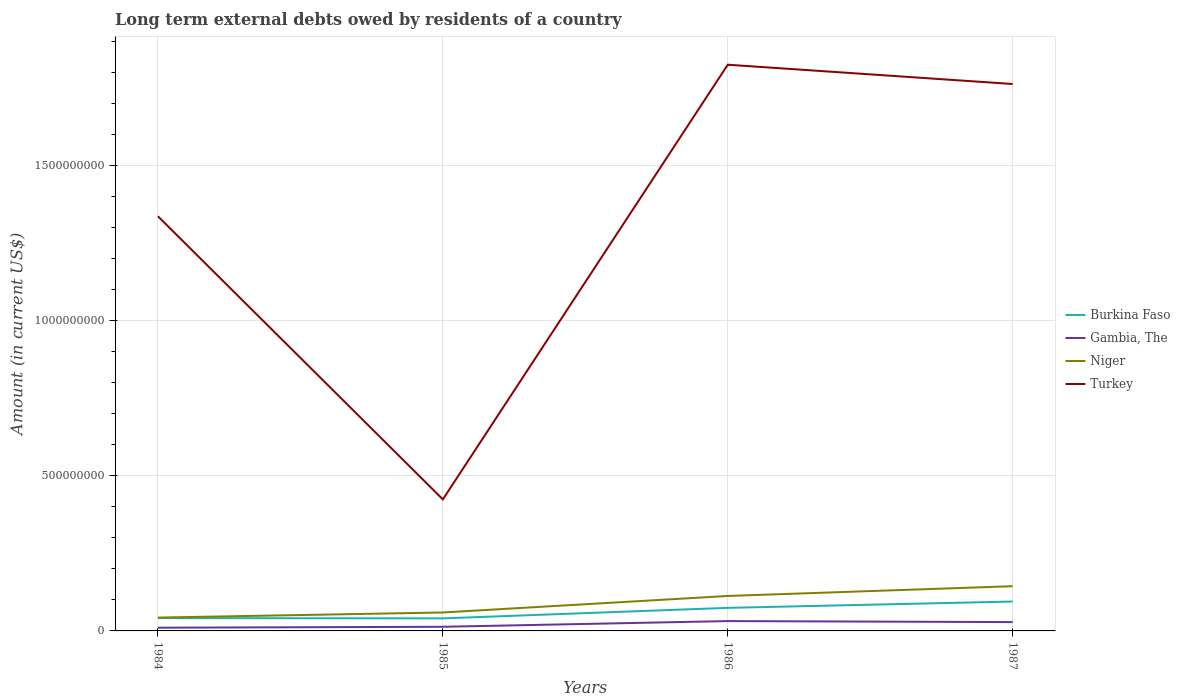How many different coloured lines are there?
Offer a very short reply. 4. Across all years, what is the maximum amount of long-term external debts owed by residents in Turkey?
Your response must be concise. 4.24e+08. What is the total amount of long-term external debts owed by residents in Burkina Faso in the graph?
Make the answer very short. 9.12e+05. What is the difference between the highest and the second highest amount of long-term external debts owed by residents in Gambia, The?
Offer a very short reply. 2.14e+07. How many lines are there?
Offer a very short reply. 4. What is the difference between two consecutive major ticks on the Y-axis?
Offer a very short reply. 5.00e+08. Does the graph contain any zero values?
Offer a terse response. No. Where does the legend appear in the graph?
Provide a succinct answer. Center right. How many legend labels are there?
Keep it short and to the point. 4. What is the title of the graph?
Give a very brief answer. Long term external debts owed by residents of a country. Does "Congo (Republic)" appear as one of the legend labels in the graph?
Make the answer very short. No. What is the label or title of the Y-axis?
Offer a terse response. Amount (in current US$). What is the Amount (in current US$) of Burkina Faso in 1984?
Your answer should be compact. 4.14e+07. What is the Amount (in current US$) of Gambia, The in 1984?
Give a very brief answer. 1.04e+07. What is the Amount (in current US$) of Niger in 1984?
Provide a succinct answer. 4.30e+07. What is the Amount (in current US$) of Turkey in 1984?
Ensure brevity in your answer.  1.34e+09. What is the Amount (in current US$) in Burkina Faso in 1985?
Offer a terse response. 4.05e+07. What is the Amount (in current US$) in Gambia, The in 1985?
Provide a succinct answer. 1.33e+07. What is the Amount (in current US$) in Niger in 1985?
Your answer should be compact. 5.95e+07. What is the Amount (in current US$) in Turkey in 1985?
Your response must be concise. 4.24e+08. What is the Amount (in current US$) of Burkina Faso in 1986?
Offer a terse response. 7.44e+07. What is the Amount (in current US$) of Gambia, The in 1986?
Offer a very short reply. 3.17e+07. What is the Amount (in current US$) in Niger in 1986?
Offer a very short reply. 1.13e+08. What is the Amount (in current US$) of Turkey in 1986?
Your response must be concise. 1.83e+09. What is the Amount (in current US$) of Burkina Faso in 1987?
Give a very brief answer. 9.48e+07. What is the Amount (in current US$) of Gambia, The in 1987?
Provide a succinct answer. 2.85e+07. What is the Amount (in current US$) of Niger in 1987?
Offer a terse response. 1.44e+08. What is the Amount (in current US$) of Turkey in 1987?
Your response must be concise. 1.76e+09. Across all years, what is the maximum Amount (in current US$) of Burkina Faso?
Offer a very short reply. 9.48e+07. Across all years, what is the maximum Amount (in current US$) of Gambia, The?
Provide a succinct answer. 3.17e+07. Across all years, what is the maximum Amount (in current US$) in Niger?
Keep it short and to the point. 1.44e+08. Across all years, what is the maximum Amount (in current US$) of Turkey?
Your answer should be compact. 1.83e+09. Across all years, what is the minimum Amount (in current US$) in Burkina Faso?
Ensure brevity in your answer.  4.05e+07. Across all years, what is the minimum Amount (in current US$) in Gambia, The?
Your answer should be compact. 1.04e+07. Across all years, what is the minimum Amount (in current US$) in Niger?
Make the answer very short. 4.30e+07. Across all years, what is the minimum Amount (in current US$) of Turkey?
Keep it short and to the point. 4.24e+08. What is the total Amount (in current US$) in Burkina Faso in the graph?
Your answer should be compact. 2.51e+08. What is the total Amount (in current US$) of Gambia, The in the graph?
Give a very brief answer. 8.39e+07. What is the total Amount (in current US$) in Niger in the graph?
Give a very brief answer. 3.60e+08. What is the total Amount (in current US$) in Turkey in the graph?
Your answer should be very brief. 5.35e+09. What is the difference between the Amount (in current US$) in Burkina Faso in 1984 and that in 1985?
Your answer should be very brief. 9.12e+05. What is the difference between the Amount (in current US$) of Gambia, The in 1984 and that in 1985?
Provide a short and direct response. -2.96e+06. What is the difference between the Amount (in current US$) of Niger in 1984 and that in 1985?
Provide a succinct answer. -1.64e+07. What is the difference between the Amount (in current US$) in Turkey in 1984 and that in 1985?
Offer a terse response. 9.13e+08. What is the difference between the Amount (in current US$) of Burkina Faso in 1984 and that in 1986?
Keep it short and to the point. -3.30e+07. What is the difference between the Amount (in current US$) in Gambia, The in 1984 and that in 1986?
Provide a short and direct response. -2.14e+07. What is the difference between the Amount (in current US$) in Niger in 1984 and that in 1986?
Give a very brief answer. -6.97e+07. What is the difference between the Amount (in current US$) of Turkey in 1984 and that in 1986?
Your answer should be very brief. -4.89e+08. What is the difference between the Amount (in current US$) of Burkina Faso in 1984 and that in 1987?
Give a very brief answer. -5.34e+07. What is the difference between the Amount (in current US$) of Gambia, The in 1984 and that in 1987?
Make the answer very short. -1.81e+07. What is the difference between the Amount (in current US$) of Niger in 1984 and that in 1987?
Provide a short and direct response. -1.01e+08. What is the difference between the Amount (in current US$) of Turkey in 1984 and that in 1987?
Give a very brief answer. -4.27e+08. What is the difference between the Amount (in current US$) in Burkina Faso in 1985 and that in 1986?
Provide a succinct answer. -3.39e+07. What is the difference between the Amount (in current US$) in Gambia, The in 1985 and that in 1986?
Ensure brevity in your answer.  -1.84e+07. What is the difference between the Amount (in current US$) in Niger in 1985 and that in 1986?
Provide a short and direct response. -5.33e+07. What is the difference between the Amount (in current US$) of Turkey in 1985 and that in 1986?
Provide a short and direct response. -1.40e+09. What is the difference between the Amount (in current US$) of Burkina Faso in 1985 and that in 1987?
Your answer should be very brief. -5.43e+07. What is the difference between the Amount (in current US$) in Gambia, The in 1985 and that in 1987?
Offer a terse response. -1.51e+07. What is the difference between the Amount (in current US$) of Niger in 1985 and that in 1987?
Provide a short and direct response. -8.48e+07. What is the difference between the Amount (in current US$) of Turkey in 1985 and that in 1987?
Keep it short and to the point. -1.34e+09. What is the difference between the Amount (in current US$) in Burkina Faso in 1986 and that in 1987?
Your response must be concise. -2.04e+07. What is the difference between the Amount (in current US$) of Gambia, The in 1986 and that in 1987?
Ensure brevity in your answer.  3.29e+06. What is the difference between the Amount (in current US$) in Niger in 1986 and that in 1987?
Your answer should be compact. -3.15e+07. What is the difference between the Amount (in current US$) in Turkey in 1986 and that in 1987?
Offer a very short reply. 6.22e+07. What is the difference between the Amount (in current US$) in Burkina Faso in 1984 and the Amount (in current US$) in Gambia, The in 1985?
Offer a terse response. 2.80e+07. What is the difference between the Amount (in current US$) of Burkina Faso in 1984 and the Amount (in current US$) of Niger in 1985?
Your response must be concise. -1.81e+07. What is the difference between the Amount (in current US$) of Burkina Faso in 1984 and the Amount (in current US$) of Turkey in 1985?
Your answer should be very brief. -3.83e+08. What is the difference between the Amount (in current US$) of Gambia, The in 1984 and the Amount (in current US$) of Niger in 1985?
Provide a short and direct response. -4.91e+07. What is the difference between the Amount (in current US$) of Gambia, The in 1984 and the Amount (in current US$) of Turkey in 1985?
Provide a short and direct response. -4.14e+08. What is the difference between the Amount (in current US$) of Niger in 1984 and the Amount (in current US$) of Turkey in 1985?
Your answer should be compact. -3.81e+08. What is the difference between the Amount (in current US$) of Burkina Faso in 1984 and the Amount (in current US$) of Gambia, The in 1986?
Offer a very short reply. 9.62e+06. What is the difference between the Amount (in current US$) of Burkina Faso in 1984 and the Amount (in current US$) of Niger in 1986?
Your answer should be compact. -7.14e+07. What is the difference between the Amount (in current US$) in Burkina Faso in 1984 and the Amount (in current US$) in Turkey in 1986?
Provide a succinct answer. -1.79e+09. What is the difference between the Amount (in current US$) in Gambia, The in 1984 and the Amount (in current US$) in Niger in 1986?
Your answer should be compact. -1.02e+08. What is the difference between the Amount (in current US$) of Gambia, The in 1984 and the Amount (in current US$) of Turkey in 1986?
Your answer should be compact. -1.82e+09. What is the difference between the Amount (in current US$) of Niger in 1984 and the Amount (in current US$) of Turkey in 1986?
Keep it short and to the point. -1.78e+09. What is the difference between the Amount (in current US$) of Burkina Faso in 1984 and the Amount (in current US$) of Gambia, The in 1987?
Provide a succinct answer. 1.29e+07. What is the difference between the Amount (in current US$) of Burkina Faso in 1984 and the Amount (in current US$) of Niger in 1987?
Your response must be concise. -1.03e+08. What is the difference between the Amount (in current US$) of Burkina Faso in 1984 and the Amount (in current US$) of Turkey in 1987?
Your answer should be compact. -1.72e+09. What is the difference between the Amount (in current US$) of Gambia, The in 1984 and the Amount (in current US$) of Niger in 1987?
Ensure brevity in your answer.  -1.34e+08. What is the difference between the Amount (in current US$) in Gambia, The in 1984 and the Amount (in current US$) in Turkey in 1987?
Offer a very short reply. -1.75e+09. What is the difference between the Amount (in current US$) of Niger in 1984 and the Amount (in current US$) of Turkey in 1987?
Your answer should be very brief. -1.72e+09. What is the difference between the Amount (in current US$) in Burkina Faso in 1985 and the Amount (in current US$) in Gambia, The in 1986?
Your answer should be compact. 8.71e+06. What is the difference between the Amount (in current US$) of Burkina Faso in 1985 and the Amount (in current US$) of Niger in 1986?
Provide a short and direct response. -7.23e+07. What is the difference between the Amount (in current US$) in Burkina Faso in 1985 and the Amount (in current US$) in Turkey in 1986?
Your answer should be very brief. -1.79e+09. What is the difference between the Amount (in current US$) of Gambia, The in 1985 and the Amount (in current US$) of Niger in 1986?
Your answer should be compact. -9.94e+07. What is the difference between the Amount (in current US$) of Gambia, The in 1985 and the Amount (in current US$) of Turkey in 1986?
Ensure brevity in your answer.  -1.81e+09. What is the difference between the Amount (in current US$) of Niger in 1985 and the Amount (in current US$) of Turkey in 1986?
Ensure brevity in your answer.  -1.77e+09. What is the difference between the Amount (in current US$) in Burkina Faso in 1985 and the Amount (in current US$) in Gambia, The in 1987?
Ensure brevity in your answer.  1.20e+07. What is the difference between the Amount (in current US$) in Burkina Faso in 1985 and the Amount (in current US$) in Niger in 1987?
Provide a short and direct response. -1.04e+08. What is the difference between the Amount (in current US$) of Burkina Faso in 1985 and the Amount (in current US$) of Turkey in 1987?
Make the answer very short. -1.72e+09. What is the difference between the Amount (in current US$) in Gambia, The in 1985 and the Amount (in current US$) in Niger in 1987?
Make the answer very short. -1.31e+08. What is the difference between the Amount (in current US$) of Gambia, The in 1985 and the Amount (in current US$) of Turkey in 1987?
Your answer should be compact. -1.75e+09. What is the difference between the Amount (in current US$) in Niger in 1985 and the Amount (in current US$) in Turkey in 1987?
Keep it short and to the point. -1.70e+09. What is the difference between the Amount (in current US$) in Burkina Faso in 1986 and the Amount (in current US$) in Gambia, The in 1987?
Your response must be concise. 4.59e+07. What is the difference between the Amount (in current US$) in Burkina Faso in 1986 and the Amount (in current US$) in Niger in 1987?
Ensure brevity in your answer.  -6.99e+07. What is the difference between the Amount (in current US$) of Burkina Faso in 1986 and the Amount (in current US$) of Turkey in 1987?
Offer a terse response. -1.69e+09. What is the difference between the Amount (in current US$) in Gambia, The in 1986 and the Amount (in current US$) in Niger in 1987?
Ensure brevity in your answer.  -1.13e+08. What is the difference between the Amount (in current US$) of Gambia, The in 1986 and the Amount (in current US$) of Turkey in 1987?
Provide a succinct answer. -1.73e+09. What is the difference between the Amount (in current US$) of Niger in 1986 and the Amount (in current US$) of Turkey in 1987?
Provide a short and direct response. -1.65e+09. What is the average Amount (in current US$) of Burkina Faso per year?
Provide a short and direct response. 6.28e+07. What is the average Amount (in current US$) in Gambia, The per year?
Offer a terse response. 2.10e+07. What is the average Amount (in current US$) of Niger per year?
Provide a succinct answer. 8.99e+07. What is the average Amount (in current US$) of Turkey per year?
Make the answer very short. 1.34e+09. In the year 1984, what is the difference between the Amount (in current US$) in Burkina Faso and Amount (in current US$) in Gambia, The?
Make the answer very short. 3.10e+07. In the year 1984, what is the difference between the Amount (in current US$) in Burkina Faso and Amount (in current US$) in Niger?
Give a very brief answer. -1.67e+06. In the year 1984, what is the difference between the Amount (in current US$) in Burkina Faso and Amount (in current US$) in Turkey?
Offer a terse response. -1.30e+09. In the year 1984, what is the difference between the Amount (in current US$) of Gambia, The and Amount (in current US$) of Niger?
Your answer should be very brief. -3.27e+07. In the year 1984, what is the difference between the Amount (in current US$) in Gambia, The and Amount (in current US$) in Turkey?
Your answer should be very brief. -1.33e+09. In the year 1984, what is the difference between the Amount (in current US$) of Niger and Amount (in current US$) of Turkey?
Your response must be concise. -1.29e+09. In the year 1985, what is the difference between the Amount (in current US$) in Burkina Faso and Amount (in current US$) in Gambia, The?
Your response must be concise. 2.71e+07. In the year 1985, what is the difference between the Amount (in current US$) in Burkina Faso and Amount (in current US$) in Niger?
Ensure brevity in your answer.  -1.90e+07. In the year 1985, what is the difference between the Amount (in current US$) of Burkina Faso and Amount (in current US$) of Turkey?
Keep it short and to the point. -3.84e+08. In the year 1985, what is the difference between the Amount (in current US$) of Gambia, The and Amount (in current US$) of Niger?
Your answer should be very brief. -4.61e+07. In the year 1985, what is the difference between the Amount (in current US$) in Gambia, The and Amount (in current US$) in Turkey?
Provide a succinct answer. -4.11e+08. In the year 1985, what is the difference between the Amount (in current US$) of Niger and Amount (in current US$) of Turkey?
Offer a very short reply. -3.65e+08. In the year 1986, what is the difference between the Amount (in current US$) in Burkina Faso and Amount (in current US$) in Gambia, The?
Your answer should be very brief. 4.27e+07. In the year 1986, what is the difference between the Amount (in current US$) of Burkina Faso and Amount (in current US$) of Niger?
Offer a terse response. -3.84e+07. In the year 1986, what is the difference between the Amount (in current US$) of Burkina Faso and Amount (in current US$) of Turkey?
Provide a short and direct response. -1.75e+09. In the year 1986, what is the difference between the Amount (in current US$) in Gambia, The and Amount (in current US$) in Niger?
Offer a very short reply. -8.10e+07. In the year 1986, what is the difference between the Amount (in current US$) in Gambia, The and Amount (in current US$) in Turkey?
Offer a very short reply. -1.79e+09. In the year 1986, what is the difference between the Amount (in current US$) of Niger and Amount (in current US$) of Turkey?
Give a very brief answer. -1.71e+09. In the year 1987, what is the difference between the Amount (in current US$) in Burkina Faso and Amount (in current US$) in Gambia, The?
Your answer should be very brief. 6.63e+07. In the year 1987, what is the difference between the Amount (in current US$) of Burkina Faso and Amount (in current US$) of Niger?
Keep it short and to the point. -4.95e+07. In the year 1987, what is the difference between the Amount (in current US$) in Burkina Faso and Amount (in current US$) in Turkey?
Your answer should be compact. -1.67e+09. In the year 1987, what is the difference between the Amount (in current US$) in Gambia, The and Amount (in current US$) in Niger?
Ensure brevity in your answer.  -1.16e+08. In the year 1987, what is the difference between the Amount (in current US$) of Gambia, The and Amount (in current US$) of Turkey?
Provide a short and direct response. -1.74e+09. In the year 1987, what is the difference between the Amount (in current US$) of Niger and Amount (in current US$) of Turkey?
Offer a terse response. -1.62e+09. What is the ratio of the Amount (in current US$) of Burkina Faso in 1984 to that in 1985?
Your response must be concise. 1.02. What is the ratio of the Amount (in current US$) of Gambia, The in 1984 to that in 1985?
Offer a very short reply. 0.78. What is the ratio of the Amount (in current US$) of Niger in 1984 to that in 1985?
Provide a succinct answer. 0.72. What is the ratio of the Amount (in current US$) in Turkey in 1984 to that in 1985?
Give a very brief answer. 3.15. What is the ratio of the Amount (in current US$) of Burkina Faso in 1984 to that in 1986?
Your response must be concise. 0.56. What is the ratio of the Amount (in current US$) of Gambia, The in 1984 to that in 1986?
Offer a terse response. 0.33. What is the ratio of the Amount (in current US$) in Niger in 1984 to that in 1986?
Offer a terse response. 0.38. What is the ratio of the Amount (in current US$) in Turkey in 1984 to that in 1986?
Keep it short and to the point. 0.73. What is the ratio of the Amount (in current US$) in Burkina Faso in 1984 to that in 1987?
Your answer should be very brief. 0.44. What is the ratio of the Amount (in current US$) in Gambia, The in 1984 to that in 1987?
Offer a terse response. 0.36. What is the ratio of the Amount (in current US$) of Niger in 1984 to that in 1987?
Make the answer very short. 0.3. What is the ratio of the Amount (in current US$) of Turkey in 1984 to that in 1987?
Provide a short and direct response. 0.76. What is the ratio of the Amount (in current US$) of Burkina Faso in 1985 to that in 1986?
Keep it short and to the point. 0.54. What is the ratio of the Amount (in current US$) of Gambia, The in 1985 to that in 1986?
Provide a succinct answer. 0.42. What is the ratio of the Amount (in current US$) of Niger in 1985 to that in 1986?
Offer a very short reply. 0.53. What is the ratio of the Amount (in current US$) of Turkey in 1985 to that in 1986?
Offer a very short reply. 0.23. What is the ratio of the Amount (in current US$) in Burkina Faso in 1985 to that in 1987?
Your answer should be very brief. 0.43. What is the ratio of the Amount (in current US$) in Gambia, The in 1985 to that in 1987?
Offer a terse response. 0.47. What is the ratio of the Amount (in current US$) in Niger in 1985 to that in 1987?
Keep it short and to the point. 0.41. What is the ratio of the Amount (in current US$) in Turkey in 1985 to that in 1987?
Your answer should be compact. 0.24. What is the ratio of the Amount (in current US$) of Burkina Faso in 1986 to that in 1987?
Offer a very short reply. 0.78. What is the ratio of the Amount (in current US$) of Gambia, The in 1986 to that in 1987?
Ensure brevity in your answer.  1.12. What is the ratio of the Amount (in current US$) in Niger in 1986 to that in 1987?
Your answer should be compact. 0.78. What is the ratio of the Amount (in current US$) of Turkey in 1986 to that in 1987?
Your response must be concise. 1.04. What is the difference between the highest and the second highest Amount (in current US$) in Burkina Faso?
Offer a very short reply. 2.04e+07. What is the difference between the highest and the second highest Amount (in current US$) of Gambia, The?
Offer a terse response. 3.29e+06. What is the difference between the highest and the second highest Amount (in current US$) in Niger?
Ensure brevity in your answer.  3.15e+07. What is the difference between the highest and the second highest Amount (in current US$) of Turkey?
Give a very brief answer. 6.22e+07. What is the difference between the highest and the lowest Amount (in current US$) in Burkina Faso?
Your answer should be very brief. 5.43e+07. What is the difference between the highest and the lowest Amount (in current US$) of Gambia, The?
Give a very brief answer. 2.14e+07. What is the difference between the highest and the lowest Amount (in current US$) in Niger?
Make the answer very short. 1.01e+08. What is the difference between the highest and the lowest Amount (in current US$) of Turkey?
Your response must be concise. 1.40e+09. 